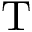Convert formula to latex. <formula><loc_0><loc_0><loc_500><loc_500>T</formula> 